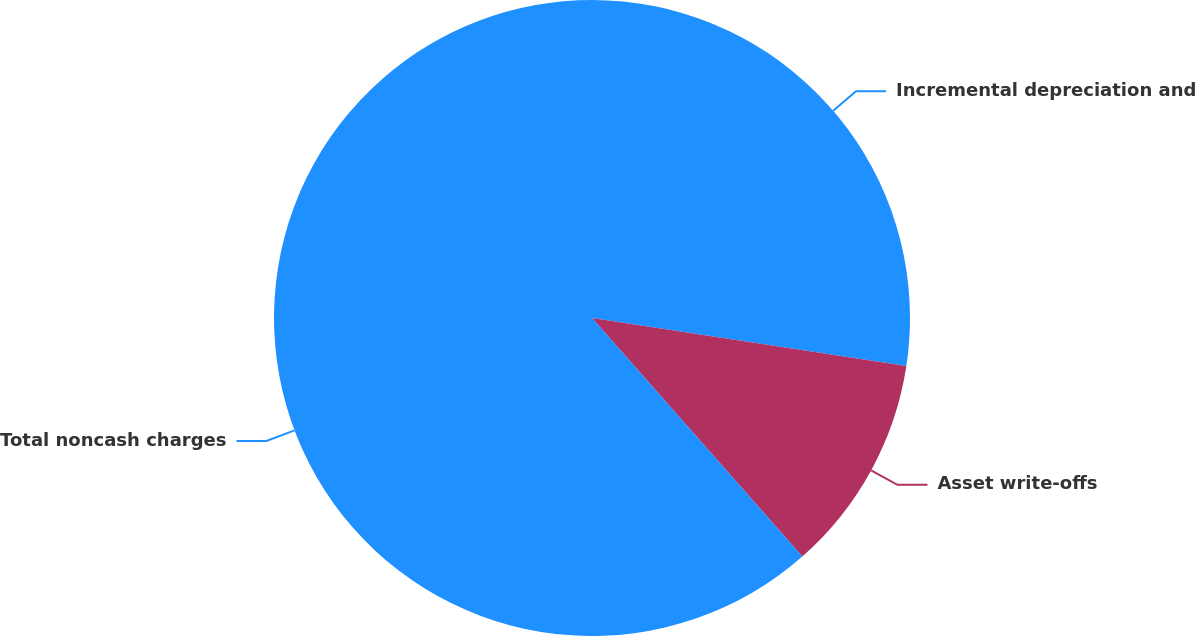Convert chart to OTSL. <chart><loc_0><loc_0><loc_500><loc_500><pie_chart><fcel>Incremental depreciation and<fcel>Asset write-offs<fcel>Total noncash charges<nl><fcel>27.41%<fcel>11.09%<fcel>61.5%<nl></chart> 